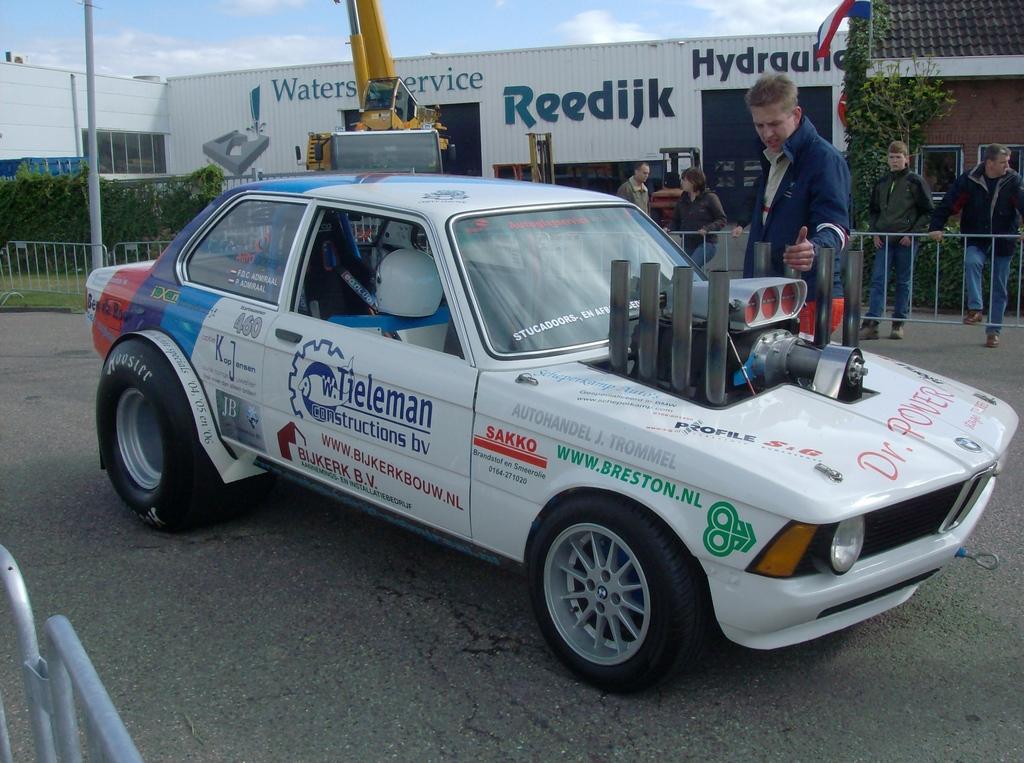Can you describe this image briefly? In this image we can see a few people, there is a car on the road, there are railings, houses, plants, there is a pole, a lag, also we can see the sky, and there are text on the wall. 